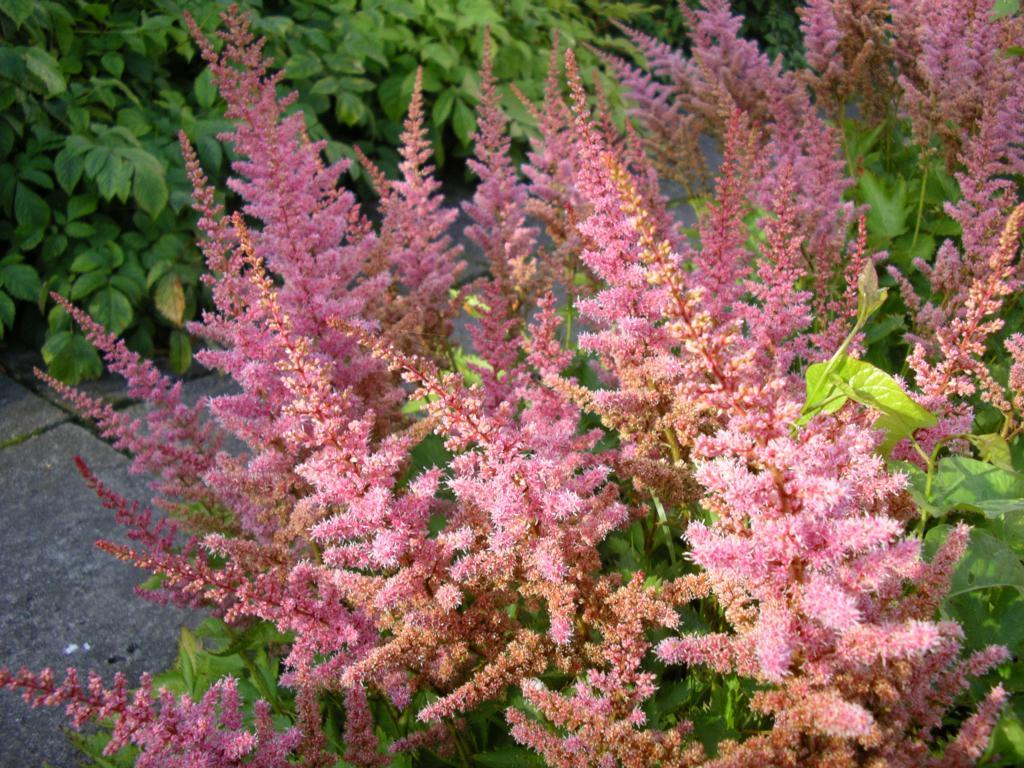What type of living organisms can be seen in the image? Plants can be seen in the image. What specific feature of the plants is visible in the image? The plants have flowers. What type of orange is being served by the minister in the image? There is no orange or minister present in the image; it features plants with flowers. What type of tank is visible in the image? There is no tank present in the image; it features plants with flowers. 